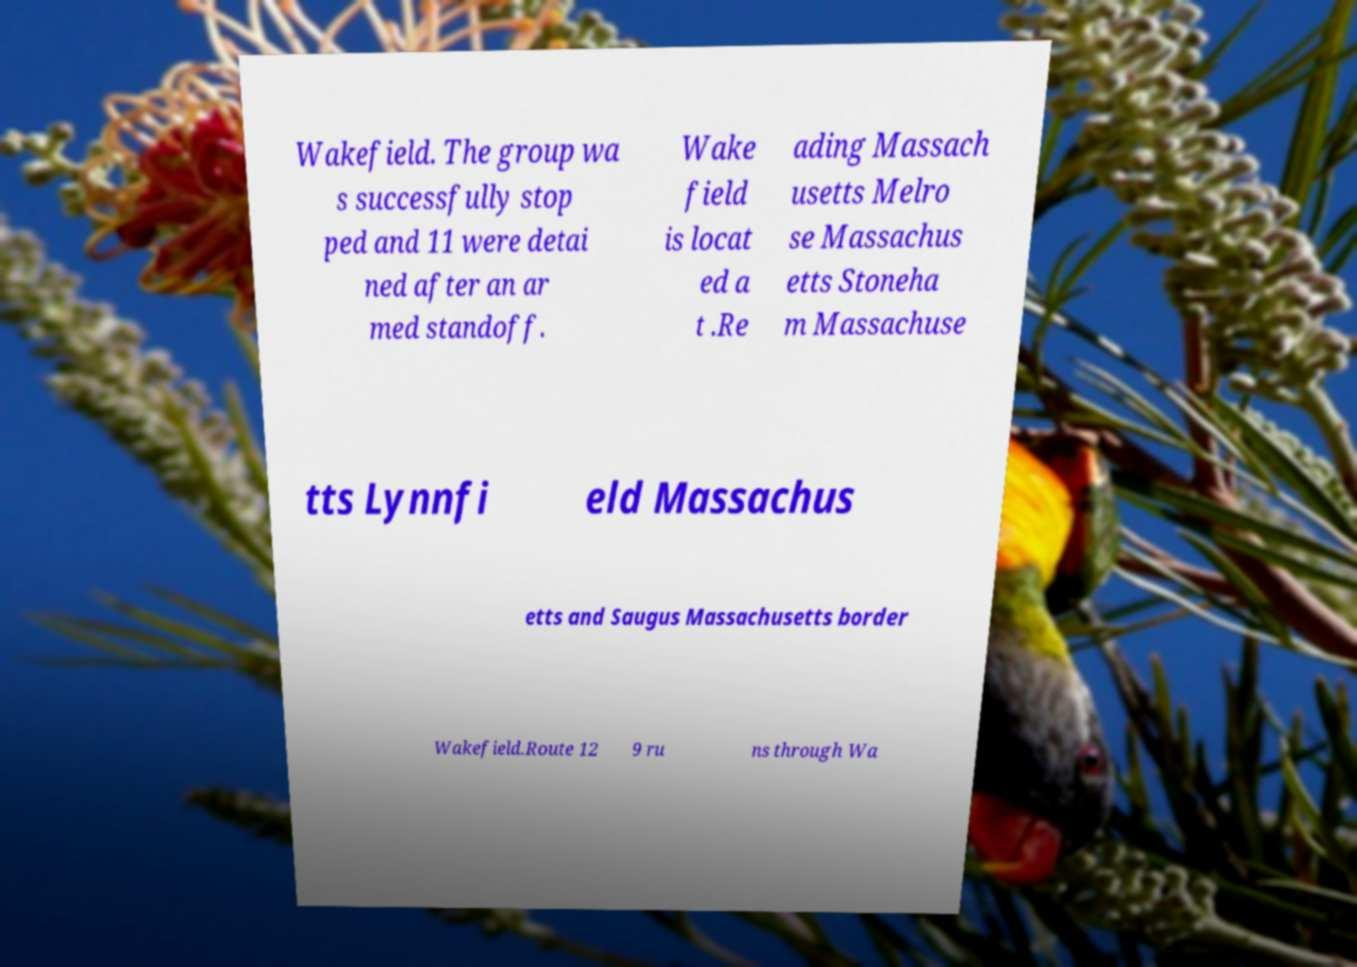Can you read and provide the text displayed in the image?This photo seems to have some interesting text. Can you extract and type it out for me? Wakefield. The group wa s successfully stop ped and 11 were detai ned after an ar med standoff. Wake field is locat ed a t .Re ading Massach usetts Melro se Massachus etts Stoneha m Massachuse tts Lynnfi eld Massachus etts and Saugus Massachusetts border Wakefield.Route 12 9 ru ns through Wa 